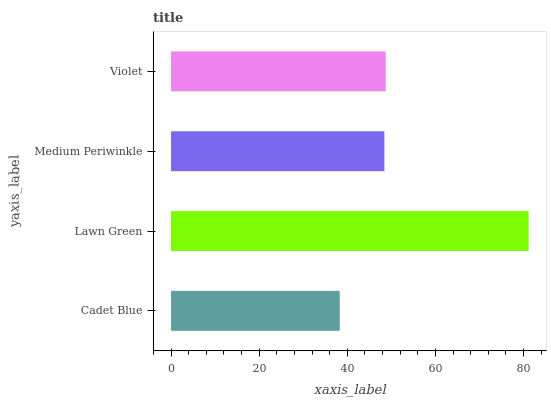Is Cadet Blue the minimum?
Answer yes or no. Yes. Is Lawn Green the maximum?
Answer yes or no. Yes. Is Medium Periwinkle the minimum?
Answer yes or no. No. Is Medium Periwinkle the maximum?
Answer yes or no. No. Is Lawn Green greater than Medium Periwinkle?
Answer yes or no. Yes. Is Medium Periwinkle less than Lawn Green?
Answer yes or no. Yes. Is Medium Periwinkle greater than Lawn Green?
Answer yes or no. No. Is Lawn Green less than Medium Periwinkle?
Answer yes or no. No. Is Violet the high median?
Answer yes or no. Yes. Is Medium Periwinkle the low median?
Answer yes or no. Yes. Is Cadet Blue the high median?
Answer yes or no. No. Is Cadet Blue the low median?
Answer yes or no. No. 